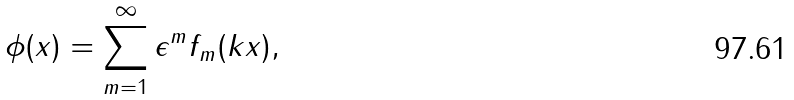<formula> <loc_0><loc_0><loc_500><loc_500>\phi ( x ) = \sum _ { m = 1 } ^ { \infty } \epsilon ^ { m } f _ { m } ( k x ) ,</formula> 